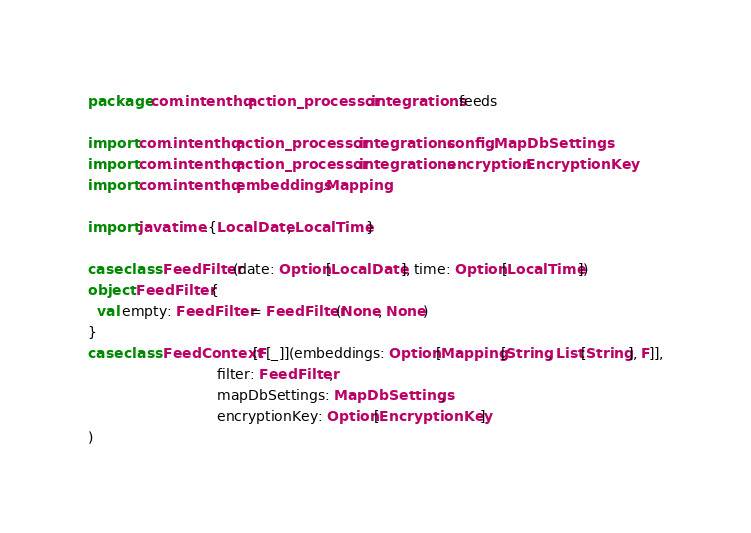<code> <loc_0><loc_0><loc_500><loc_500><_Scala_>package com.intenthq.action_processor.integrations.feeds

import com.intenthq.action_processor.integrations.config.MapDbSettings
import com.intenthq.action_processor.integrations.encryption.EncryptionKey
import com.intenthq.embeddings.Mapping

import java.time.{LocalDate, LocalTime}

case class FeedFilter(date: Option[LocalDate], time: Option[LocalTime])
object FeedFilter {
  val empty: FeedFilter = FeedFilter(None, None)
}
case class FeedContext[F[_]](embeddings: Option[Mapping[String, List[String], F]],
                             filter: FeedFilter,
                             mapDbSettings: MapDbSettings,
                             encryptionKey: Option[EncryptionKey]
)
</code> 